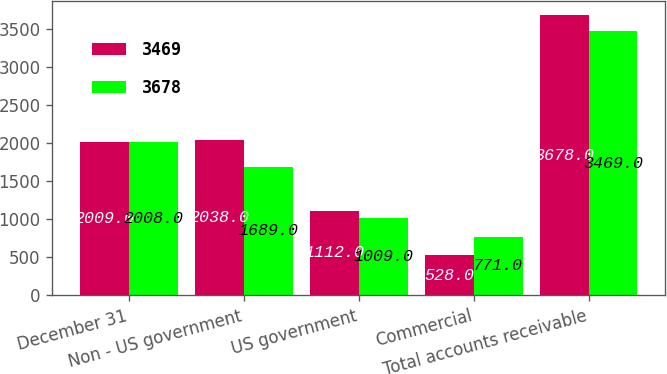<chart> <loc_0><loc_0><loc_500><loc_500><stacked_bar_chart><ecel><fcel>December 31<fcel>Non - US government<fcel>US government<fcel>Commercial<fcel>Total accounts receivable<nl><fcel>3469<fcel>2009<fcel>2038<fcel>1112<fcel>528<fcel>3678<nl><fcel>3678<fcel>2008<fcel>1689<fcel>1009<fcel>771<fcel>3469<nl></chart> 